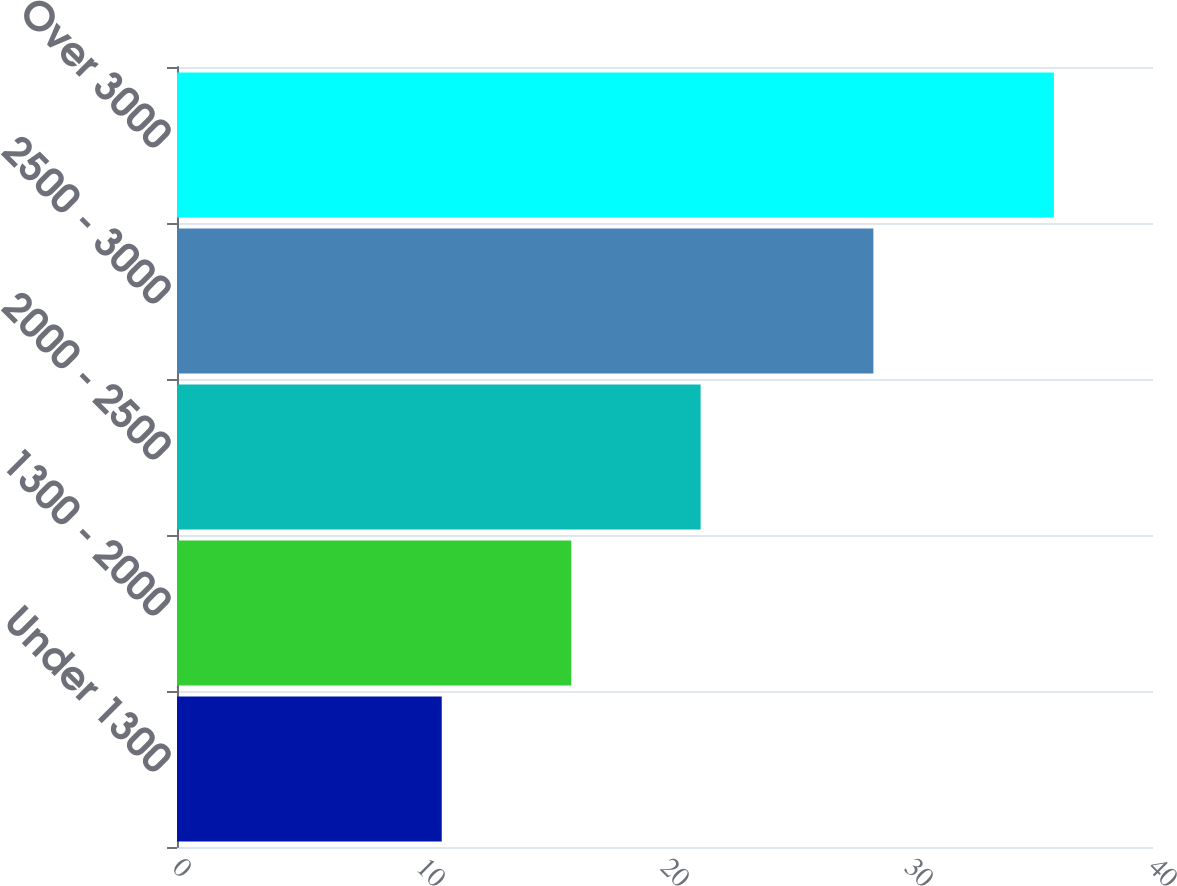Convert chart. <chart><loc_0><loc_0><loc_500><loc_500><bar_chart><fcel>Under 1300<fcel>1300 - 2000<fcel>2000 - 2500<fcel>2500 - 3000<fcel>Over 3000<nl><fcel>10.85<fcel>16.16<fcel>21.46<fcel>28.54<fcel>35.94<nl></chart> 